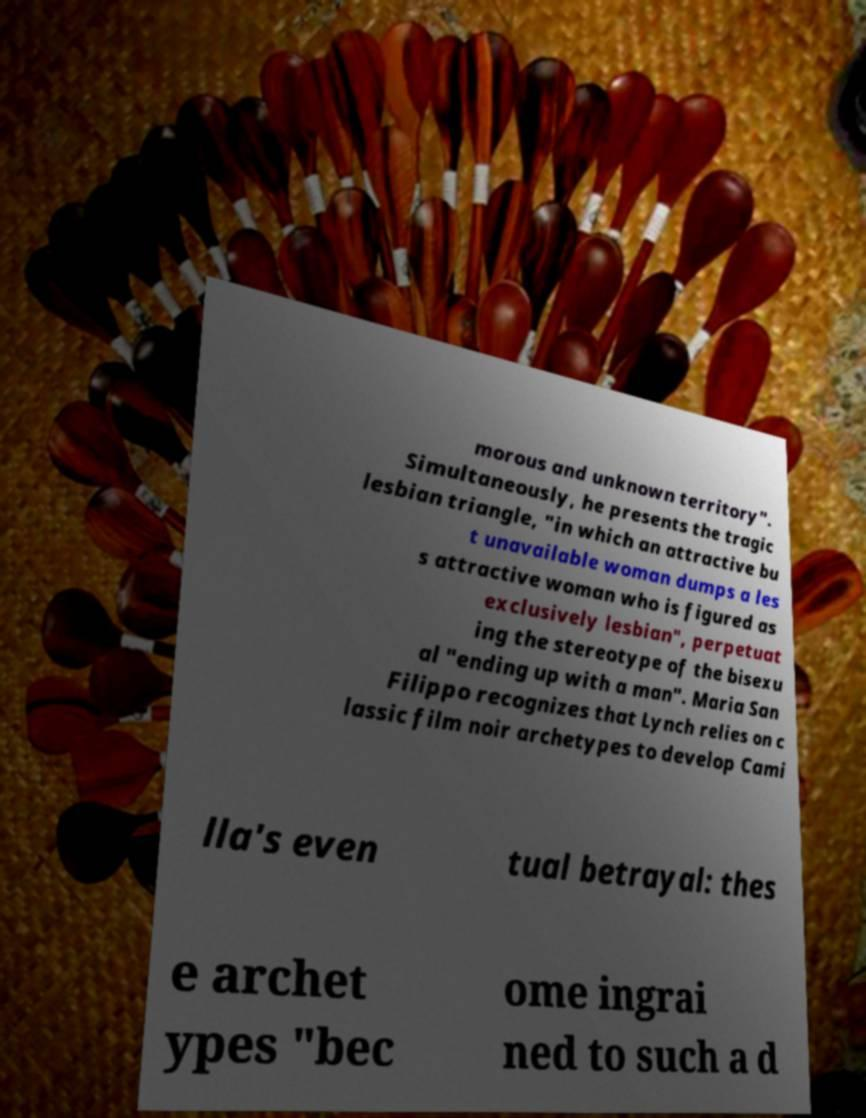What messages or text are displayed in this image? I need them in a readable, typed format. morous and unknown territory". Simultaneously, he presents the tragic lesbian triangle, "in which an attractive bu t unavailable woman dumps a les s attractive woman who is figured as exclusively lesbian", perpetuat ing the stereotype of the bisexu al "ending up with a man". Maria San Filippo recognizes that Lynch relies on c lassic film noir archetypes to develop Cami lla's even tual betrayal: thes e archet ypes "bec ome ingrai ned to such a d 